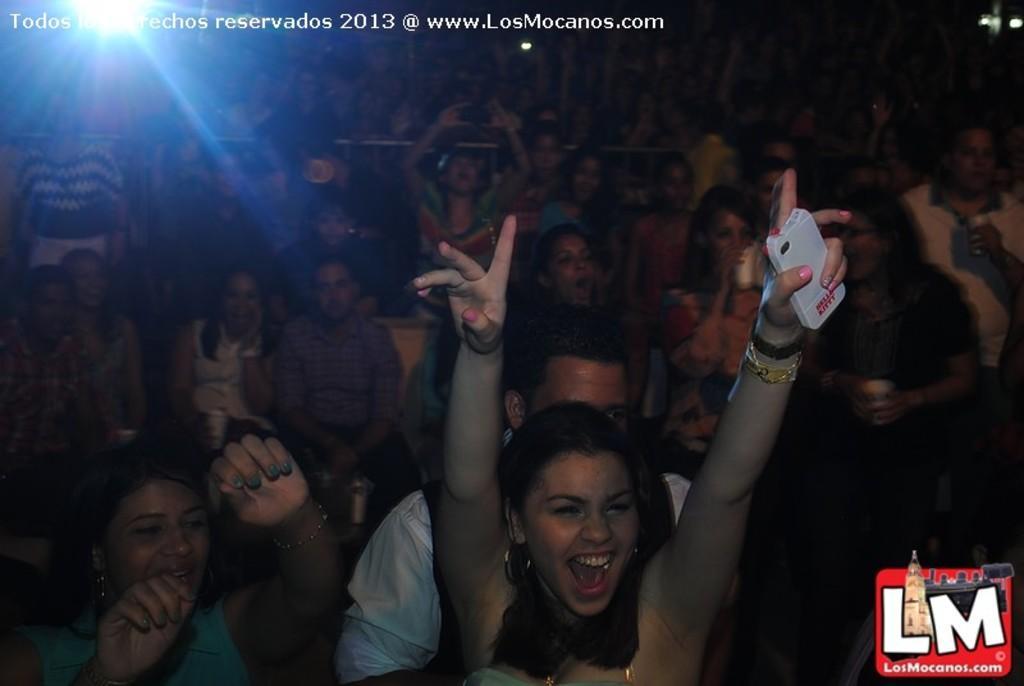In one or two sentences, can you explain what this image depicts? There are people some are standing and sitting in the foreground area of the image, there is light in the background and text at the top side. 